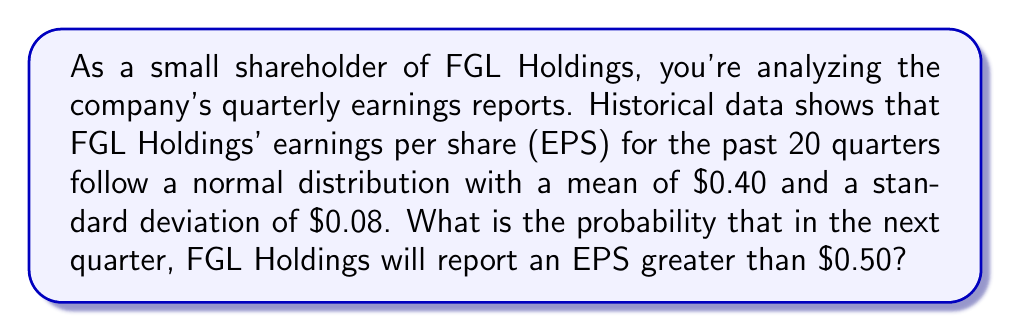What is the answer to this math problem? To solve this problem, we need to use the properties of the normal distribution and the concept of z-scores.

1. We are given that the EPS follows a normal distribution with:
   Mean (μ) = $0.40
   Standard deviation (σ) = $0.08

2. We want to find P(EPS > $0.50)

3. To standardize this, we need to calculate the z-score for $0.50:

   $$z = \frac{x - \mu}{\sigma} = \frac{0.50 - 0.40}{0.08} = 1.25$$

4. Now, we need to find the probability of z > 1.25 in a standard normal distribution.

5. Using a standard normal distribution table or calculator, we can find that:
   P(z > 1.25) ≈ 0.1056

6. Therefore, the probability of FGL Holdings reporting an EPS greater than $0.50 in the next quarter is approximately 0.1056 or 10.56%.

[asy]
import graph;
size(200,150);

real f(real x) {return exp(-x^2/2)/sqrt(2pi);}

draw(graph(f,-3,3),blue);
fill(graph(f,1.25,3),blue,0.2);

label("$\mu=0.40$",(0,-0.05),S);
label("$0.50$",(1.25,-0.05),S);

draw((1.25,0)--(1.25,f(1.25)),dashed);
draw((-3,0)--(3,0),Arrow);

label("10.56%",(2,0.15));
[/asy]
Answer: The probability that FGL Holdings will report an EPS greater than $0.50 in the next quarter is approximately 10.56%. 